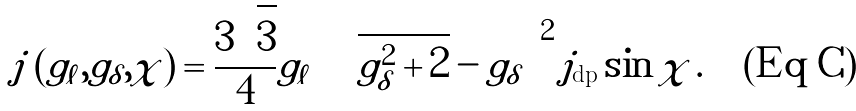<formula> <loc_0><loc_0><loc_500><loc_500>j \left ( g _ { \ell } , g _ { \delta } , \chi \right ) = \frac { 3 \sqrt { 3 } } { 4 } g _ { \ell } \left ( \sqrt { g _ { \delta } ^ { 2 } + 2 } - g _ { \delta } \right ) ^ { 2 } j _ { \text {dp} } \sin \chi \, .</formula> 